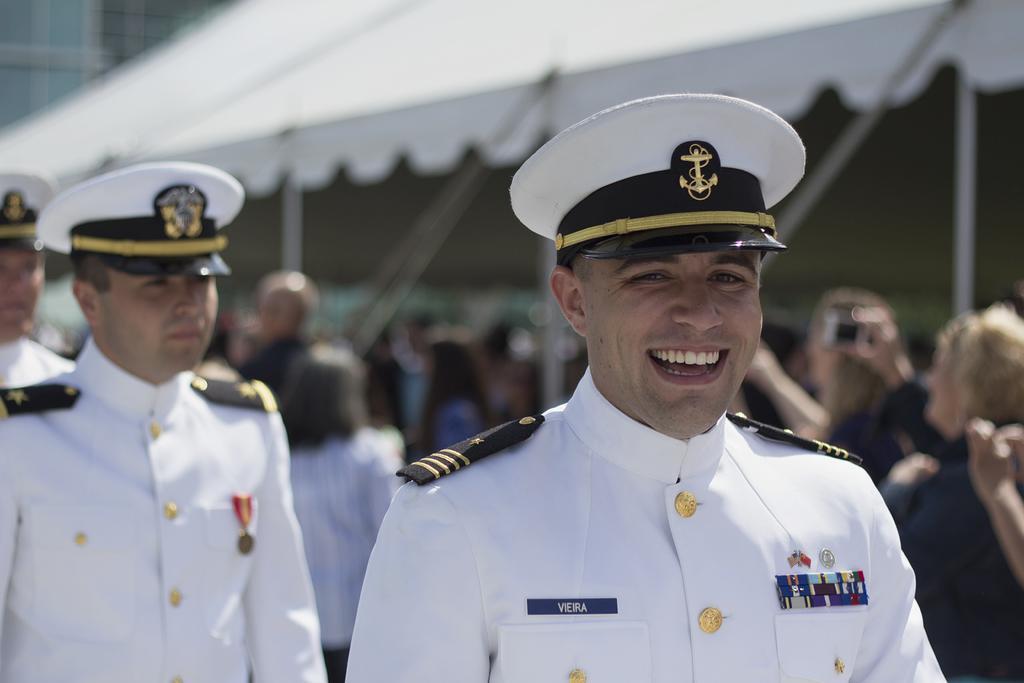How would you summarize this image in a sentence or two? In this image we can see three people standing wearing a hat. On the backside we can see a group of people under a tent. 